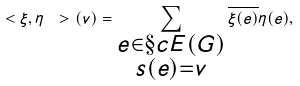<formula> <loc_0><loc_0><loc_500><loc_500>\ < \xi , \eta \ > ( v ) = \sum _ { \substack { e \in \S c { E } ( G ) \\ s ( e ) = v } } \overline { \xi ( e ) } \eta ( e ) ,</formula> 